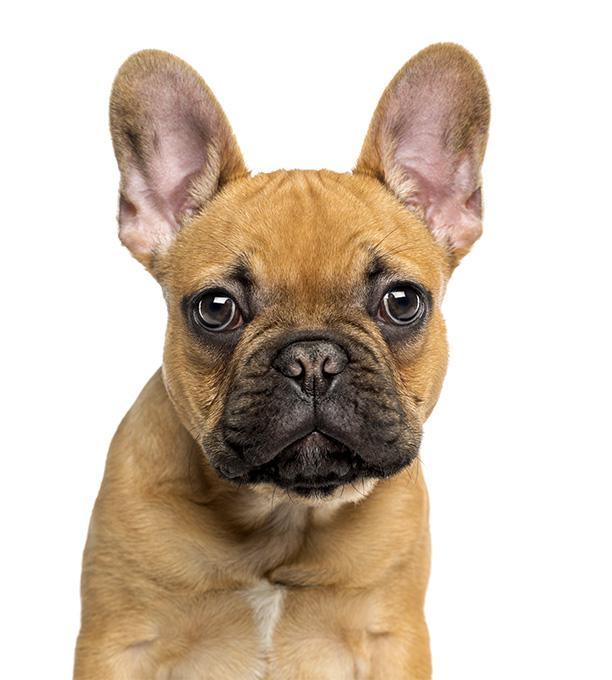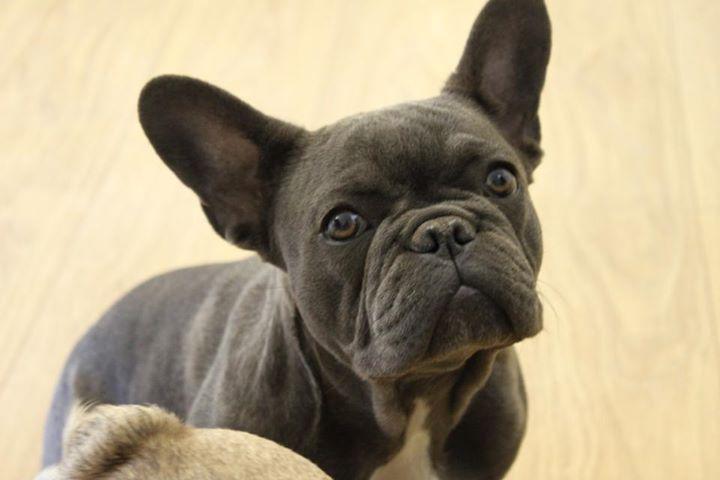The first image is the image on the left, the second image is the image on the right. For the images shown, is this caption "A dog is wearing a collar." true? Answer yes or no. No. 